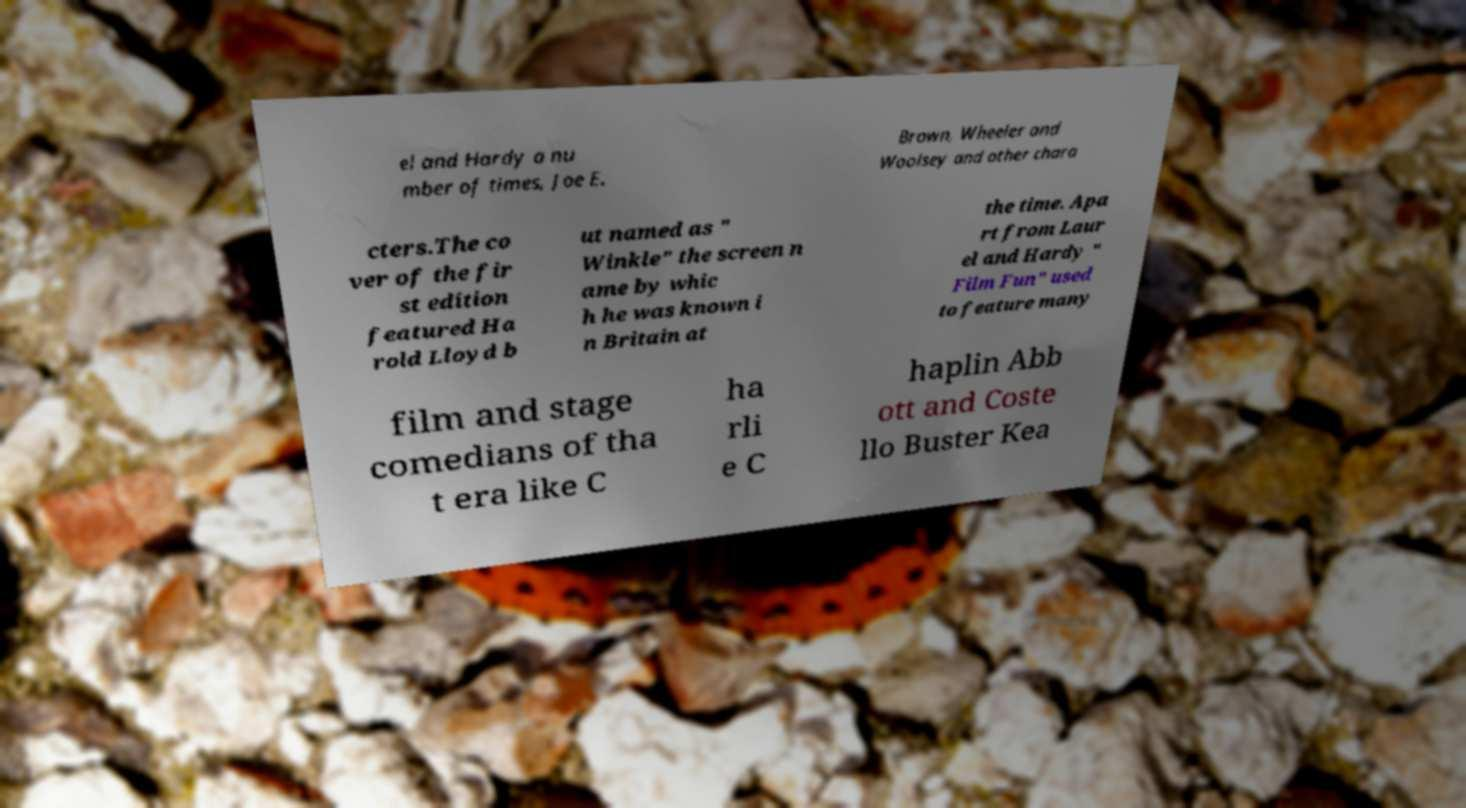Could you extract and type out the text from this image? el and Hardy a nu mber of times, Joe E. Brown, Wheeler and Woolsey and other chara cters.The co ver of the fir st edition featured Ha rold Lloyd b ut named as " Winkle" the screen n ame by whic h he was known i n Britain at the time. Apa rt from Laur el and Hardy " Film Fun" used to feature many film and stage comedians of tha t era like C ha rli e C haplin Abb ott and Coste llo Buster Kea 